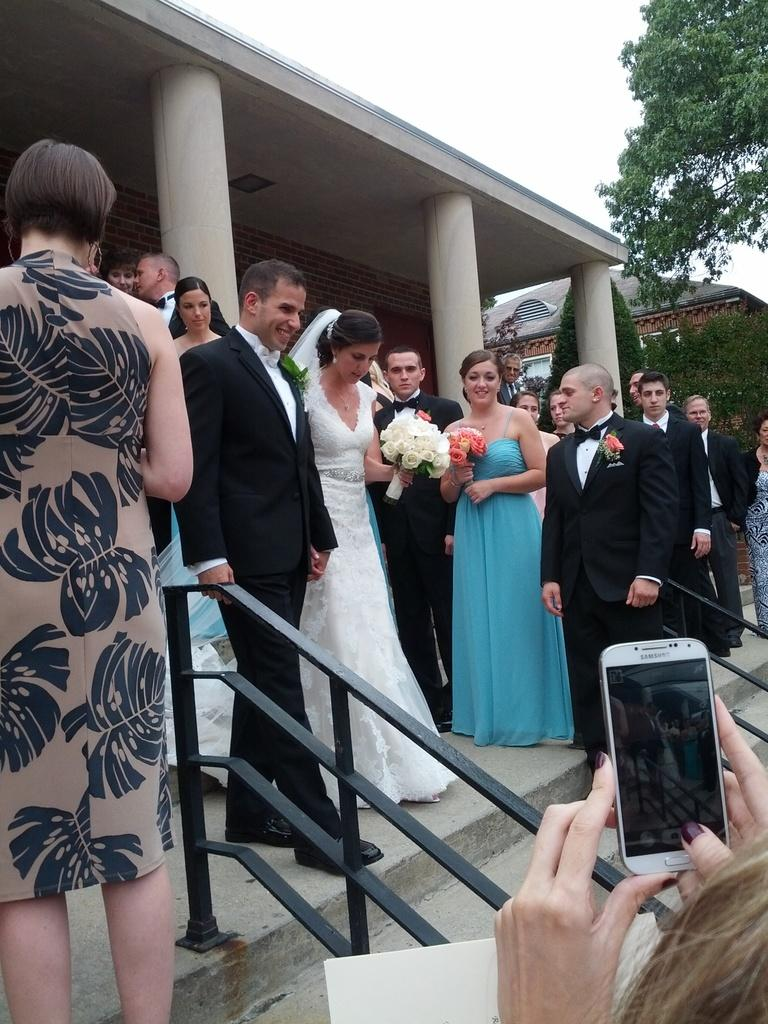Who are the main subjects in the image? There is a newly married couple in the image. What are the couple doing in the image? The couple is walking out. Are there any other people present in the image? Yes, there are people around the couple. What is the woman with the mobile phone doing? The woman is taking their picture. What device is the woman using to take the picture? The woman is using a mobile phone to take the picture. What type of boundary can be seen in the image? There is no boundary present in the image. Can you see any smoke coming from the couple in the image? No, there is no smoke visible in the image. 